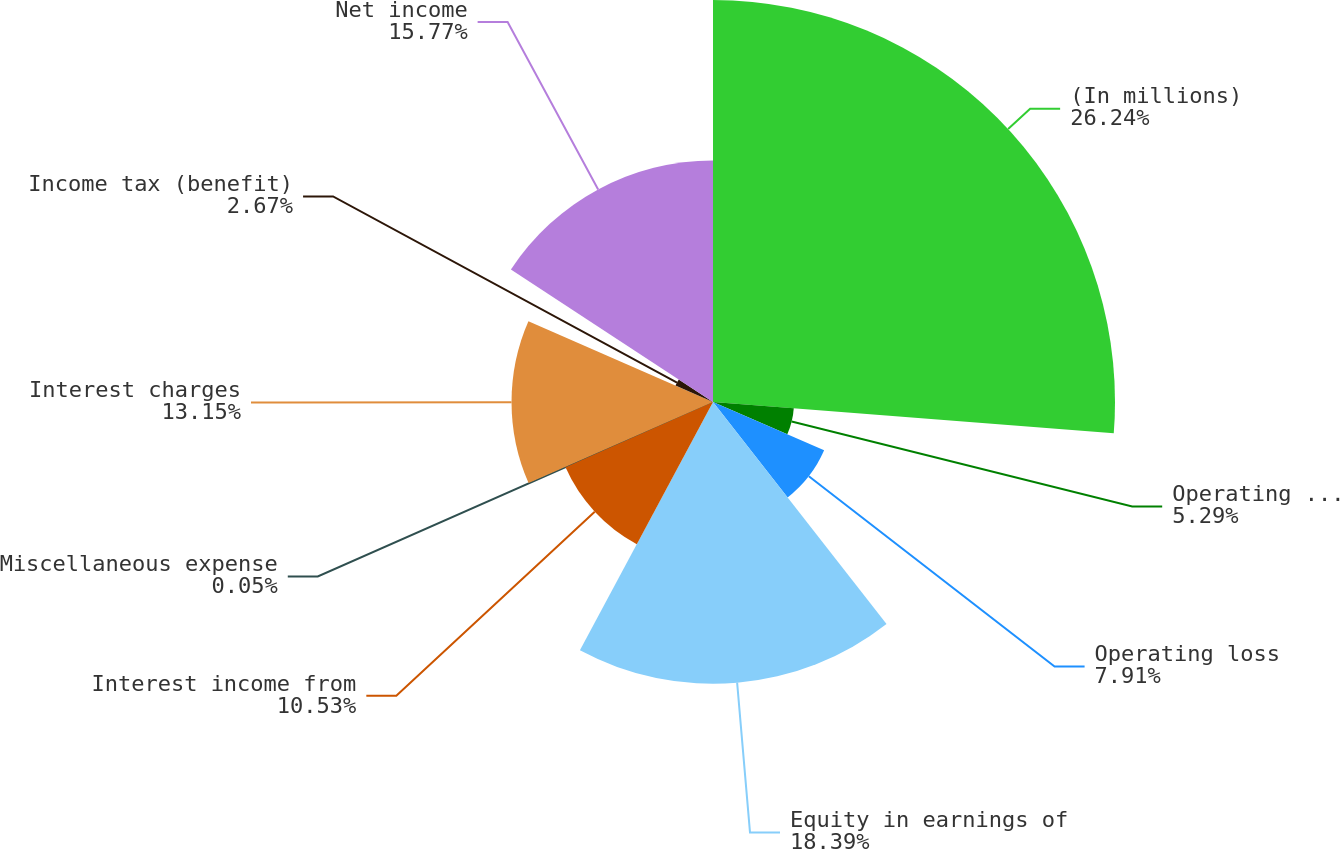<chart> <loc_0><loc_0><loc_500><loc_500><pie_chart><fcel>(In millions)<fcel>Operating expenses<fcel>Operating loss<fcel>Equity in earnings of<fcel>Interest income from<fcel>Miscellaneous expense<fcel>Interest charges<fcel>Income tax (benefit)<fcel>Net income<nl><fcel>26.24%<fcel>5.29%<fcel>7.91%<fcel>18.39%<fcel>10.53%<fcel>0.05%<fcel>13.15%<fcel>2.67%<fcel>15.77%<nl></chart> 